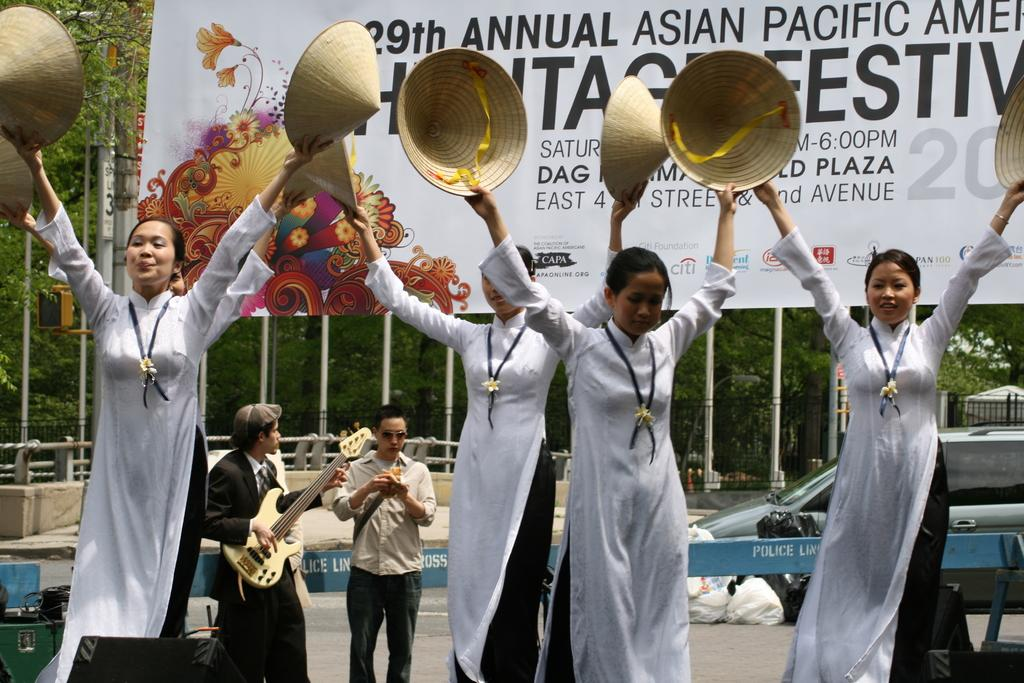What type of plant can be seen in the image? There is a tree in the image. What is hanging or attached in the image? There is a banner in the image. What type of barrier is visible in the image? There is a fence in the image. What mode of transportation can be seen in the image? There is a car on the road in the image. What are the people in the image doing? There are people standing in the image. Can you describe the woman in the image? A woman is standing in the image and holding a guitar. What type of horn can be heard in the image? There is no audible sound in the image, so it is not possible to determine if a horn can be heard. What type of coach is present in the image? There is no coach present in the image. 